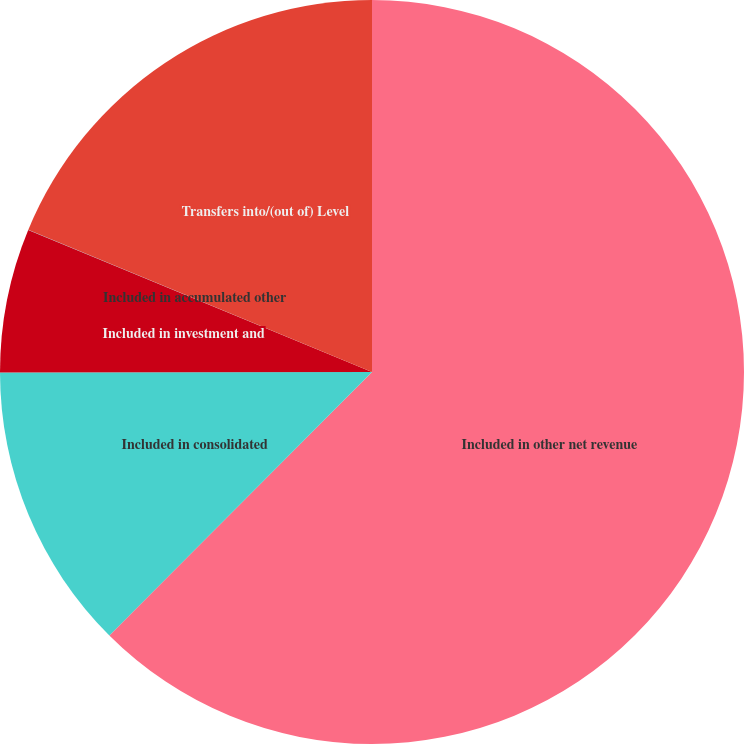Convert chart. <chart><loc_0><loc_0><loc_500><loc_500><pie_chart><fcel>Included in other net revenue<fcel>Included in consolidated<fcel>Included in investment and<fcel>Included in accumulated other<fcel>Transfers into/(out of) Level<nl><fcel>62.47%<fcel>12.5%<fcel>6.26%<fcel>0.01%<fcel>18.75%<nl></chart> 